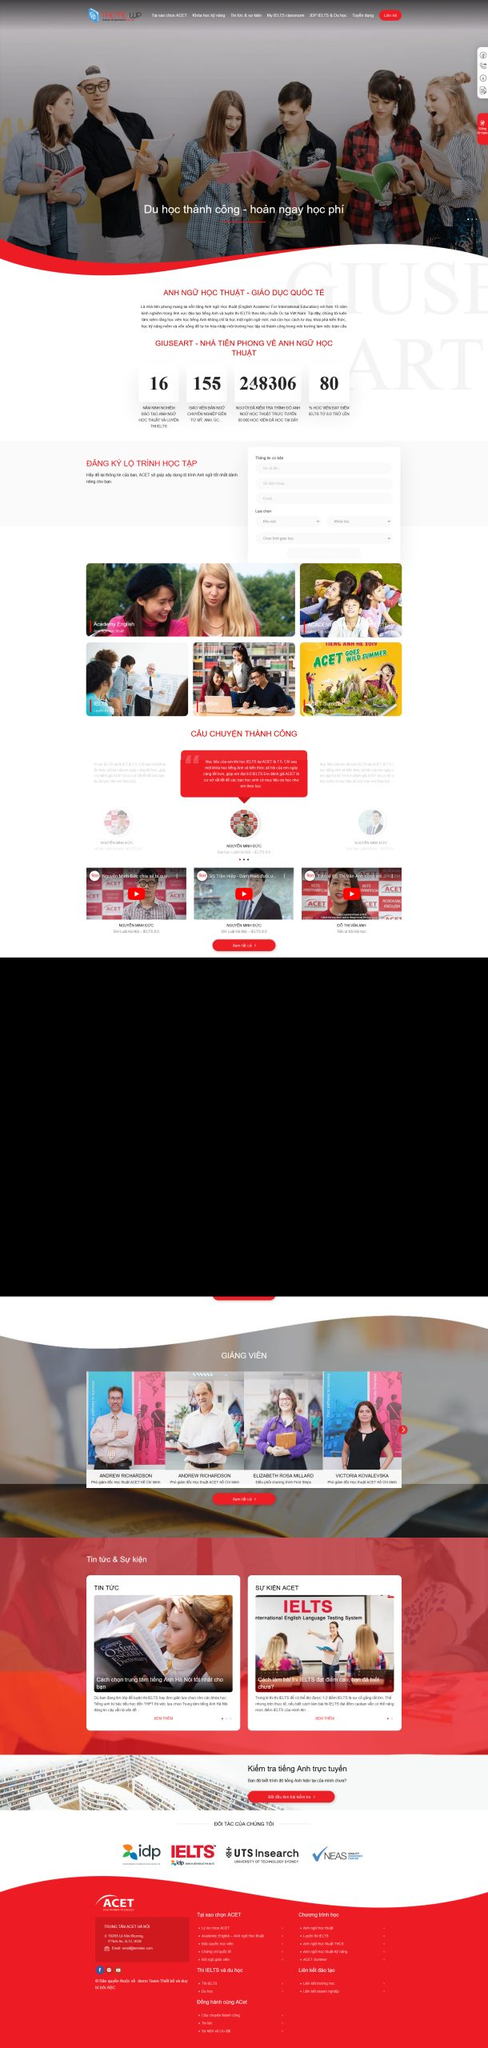Liệt kê 5 ngành nghề, lĩnh vực phù hợp với website này, phân cách các màu sắc bằng dấu phẩy. Chỉ trả về kết quả, phân cách bằng dấy phẩy
 Giáo dục, Đào tạo tiếng Anh, Du học, Luyện thi IELTS, Hội thảo giáo dục 